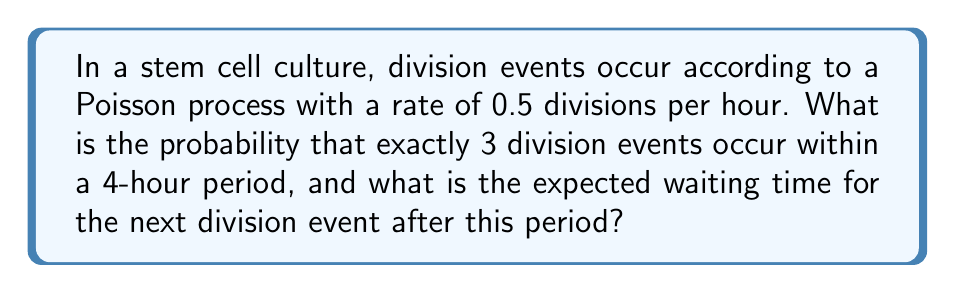Give your solution to this math problem. Let's approach this problem step-by-step:

1. Probability of exactly 3 division events in 4 hours:
   - The number of events in a Poisson process follows a Poisson distribution.
   - The rate parameter λ for a 4-hour period is: λ = 0.5 * 4 = 2
   - The probability of exactly k events is given by:
     $$ P(X = k) = \frac{e^{-\lambda}\lambda^k}{k!} $$
   - For k = 3 and λ = 2:
     $$ P(X = 3) = \frac{e^{-2}2^3}{3!} = \frac{e^{-2}8}{6} \approx 0.1804 $$

2. Expected waiting time for the next division event:
   - The Poisson process has the memoryless property, meaning the waiting time for the next event is independent of the past.
   - The waiting times between events in a Poisson process follow an exponential distribution.
   - The expected value (mean) of an exponential distribution is the inverse of the rate parameter.
   - The rate parameter is 0.5 divisions per hour, so:
     $$ E[T] = \frac{1}{0.5} = 2 \text{ hours} $$

Therefore, the probability of exactly 3 division events in 4 hours is approximately 0.1804, and the expected waiting time for the next division event is 2 hours.
Answer: P(X = 3) ≈ 0.1804, E[T] = 2 hours 